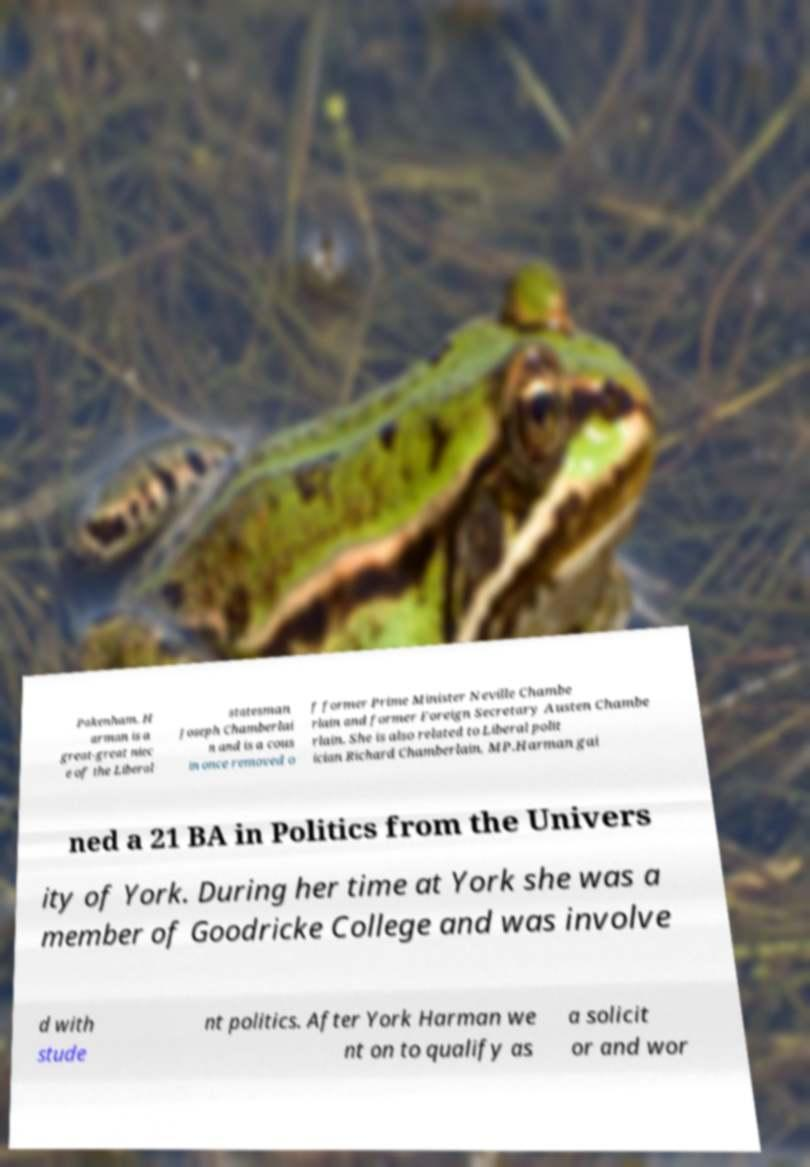I need the written content from this picture converted into text. Can you do that? Pakenham. H arman is a great-great niec e of the Liberal statesman Joseph Chamberlai n and is a cous in once removed o f former Prime Minister Neville Chambe rlain and former Foreign Secretary Austen Chambe rlain. She is also related to Liberal polit ician Richard Chamberlain, MP.Harman gai ned a 21 BA in Politics from the Univers ity of York. During her time at York she was a member of Goodricke College and was involve d with stude nt politics. After York Harman we nt on to qualify as a solicit or and wor 